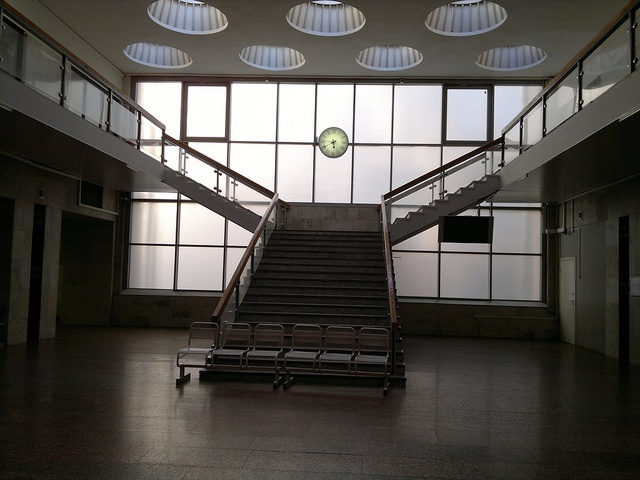Describe the objects in this image and their specific colors. I can see bench in black and gray tones, chair in black and gray tones, chair in black and gray tones, tv in black and gray tones, and chair in black and gray tones in this image. 